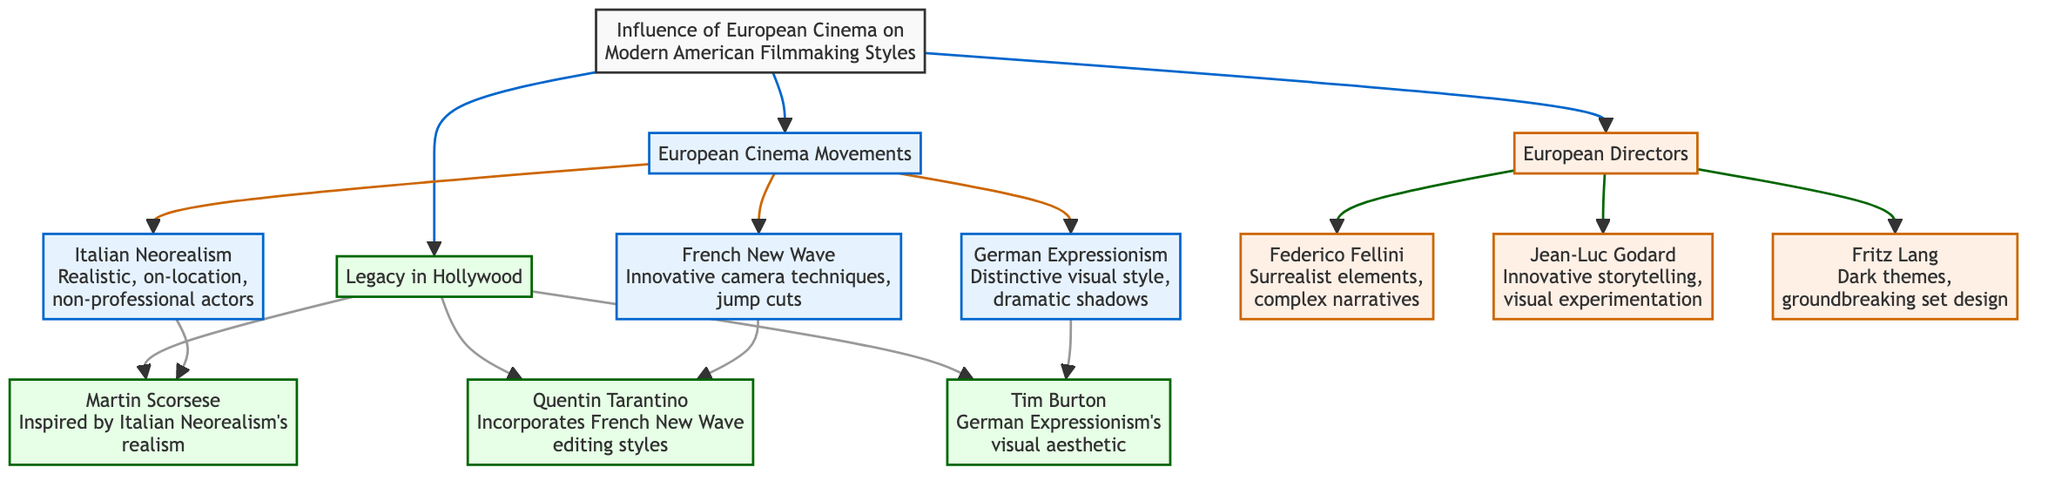What is the main focus of the diagram? The main focus of the diagram is to depict the "Influence of European Cinema on Modern American Filmmaking Styles," as indicated in the central node.
Answer: Influence of European Cinema on Modern American Filmmaking Styles How many European cinema movements are listed in the diagram? The diagram lists three European cinema movements: Italian Neorealism, French New Wave, and German Expressionism. This can be counted from the movements section.
Answer: 3 Name one director associated with the French New Wave. The French New Wave is associated with director Jean-Luc Godard, as indicated in the directors section that outlines individuals linked to different movements.
Answer: Jean-Luc Godard What type of cinematic theme is Fritz Lang known for? Fritz Lang is known for dark themes, as indicated in the description next to his name in the directors section of the diagram.
Answer: Dark themes Which modern American director incorporates French New Wave editing styles? The diagram shows that Quentin Tarantino incorporates French New Wave editing styles, as noted in the legacy section related to his influence.
Answer: Quentin Tarantino How does Martin Scorsese's filmmaking relate to Italian Neorealism? Martin Scorsese is inspired by Italian Neorealism's realism, which ties his work back to one of the European cinema movements mentioned in the diagram, specifically its influence on his style.
Answer: Inspired by Italian Neorealism's realism What visual characteristic is associated with Tim Burton's work? Tim Burton's work is associated with the visual aesthetic of German Expressionism, as noted in the legacy section connecting him to this movement.
Answer: German Expressionism's visual aesthetic What is a unique feature of the German Expressionism movement mentioned in the diagram? The unique feature mentioned for German Expressionism is its distinctive visual style and dramatic shadows, which encapsulates its artistic approach.
Answer: Distinctive visual style, dramatic shadows Which director is known for complex narratives and surrealist elements? The diagram associates Federico Fellini with complex narratives and surrealist elements, indicating his unique contribution to European cinema.
Answer: Federico Fellini 